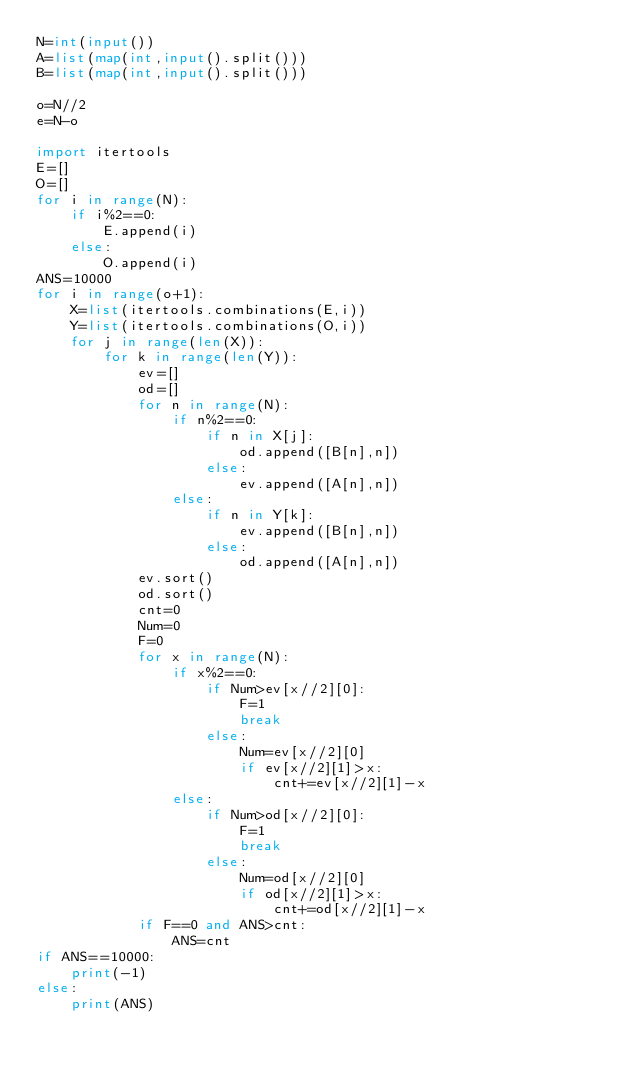Convert code to text. <code><loc_0><loc_0><loc_500><loc_500><_Python_>N=int(input())
A=list(map(int,input().split()))
B=list(map(int,input().split()))

o=N//2
e=N-o

import itertools
E=[]
O=[]
for i in range(N):
    if i%2==0:
        E.append(i)
    else:
        O.append(i)
ANS=10000
for i in range(o+1):
    X=list(itertools.combinations(E,i))
    Y=list(itertools.combinations(O,i))
    for j in range(len(X)):
        for k in range(len(Y)):
            ev=[]
            od=[]
            for n in range(N):
                if n%2==0:
                    if n in X[j]:
                        od.append([B[n],n])
                    else:
                        ev.append([A[n],n])
                else:
                    if n in Y[k]:
                        ev.append([B[n],n])
                    else:
                        od.append([A[n],n])
            ev.sort()
            od.sort()
            cnt=0
            Num=0
            F=0
            for x in range(N):
                if x%2==0:
                    if Num>ev[x//2][0]:
                        F=1
                        break
                    else:
                        Num=ev[x//2][0]
                        if ev[x//2][1]>x:
                            cnt+=ev[x//2][1]-x
                else:
                    if Num>od[x//2][0]:
                        F=1
                        break
                    else:
                        Num=od[x//2][0]
                        if od[x//2][1]>x:
                            cnt+=od[x//2][1]-x
            if F==0 and ANS>cnt:
                ANS=cnt
if ANS==10000:
    print(-1)
else:
    print(ANS)
    </code> 